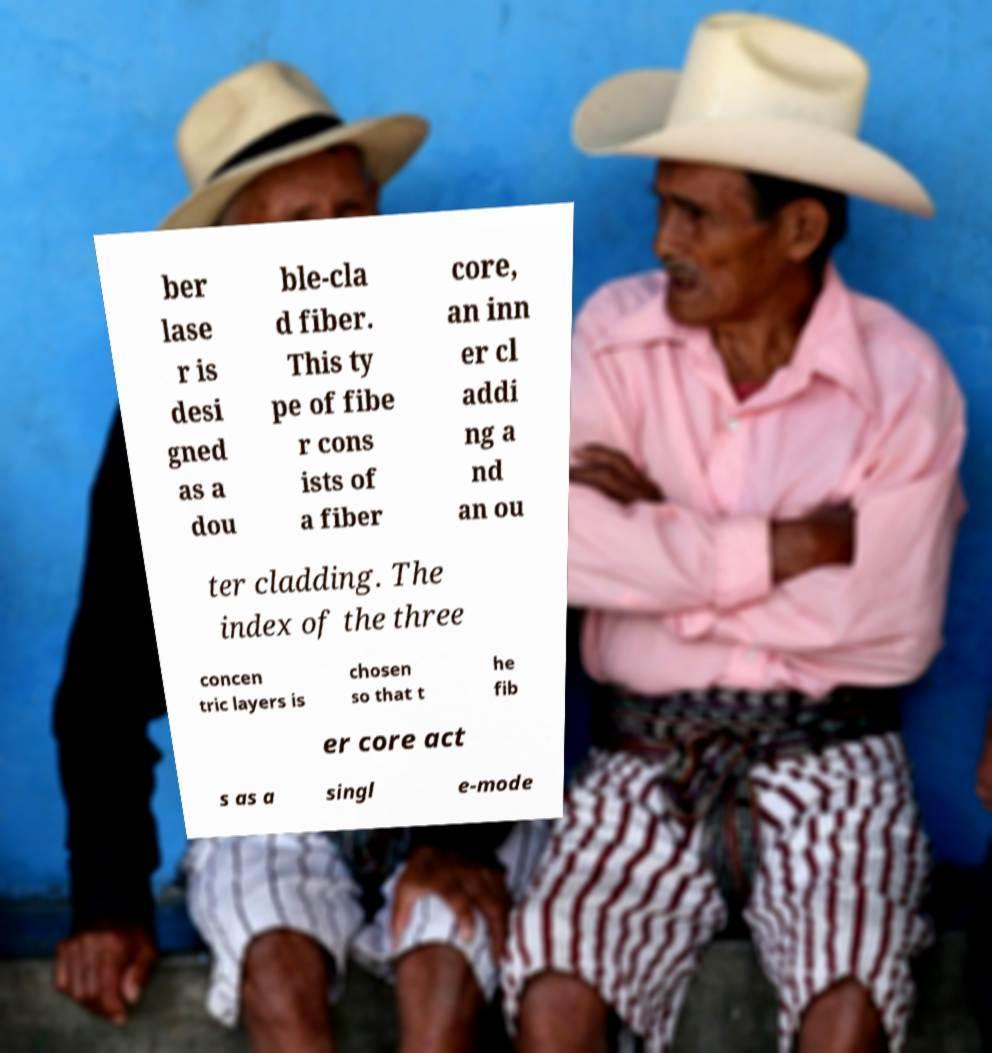What messages or text are displayed in this image? I need them in a readable, typed format. ber lase r is desi gned as a dou ble-cla d fiber. This ty pe of fibe r cons ists of a fiber core, an inn er cl addi ng a nd an ou ter cladding. The index of the three concen tric layers is chosen so that t he fib er core act s as a singl e-mode 